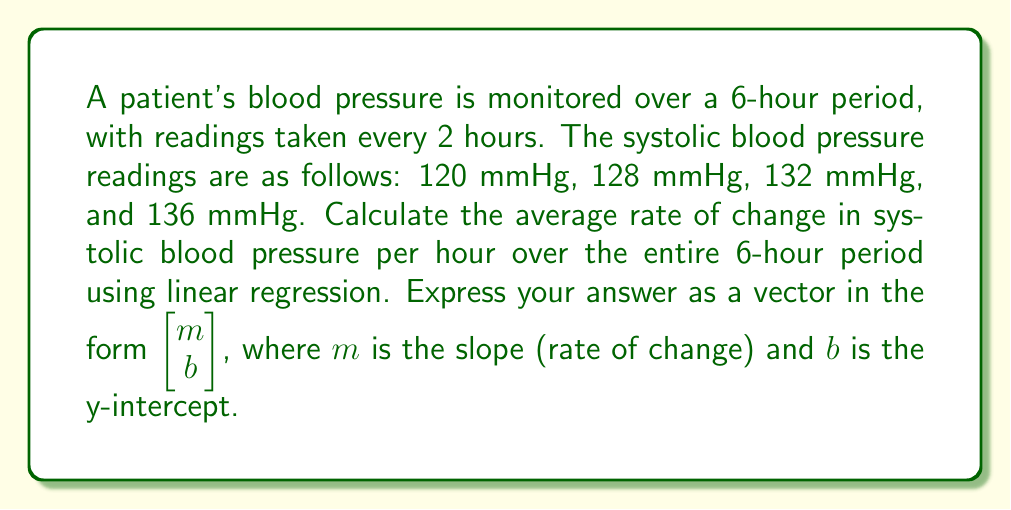What is the answer to this math problem? To solve this problem, we'll use linear regression to find the line of best fit for the blood pressure readings over time. We'll use the following steps:

1) Set up the data points:
   $x$ (hours): 0, 2, 4, 6
   $y$ (mmHg): 120, 128, 132, 136

2) Calculate the means of $x$ and $y$:
   $\bar{x} = \frac{0 + 2 + 4 + 6}{4} = 3$
   $\bar{y} = \frac{120 + 128 + 132 + 136}{4} = 129$

3) Calculate the slope $m$ using the formula:
   $$m = \frac{\sum(x_i - \bar{x})(y_i - \bar{y})}{\sum(x_i - \bar{x})^2}$$

4) Compute the numerator and denominator:
   $\sum(x_i - \bar{x})(y_i - \bar{y}) = (-3)(-9) + (-1)(-1) + (1)(3) + (3)(7) = 27 + 1 + 3 + 21 = 52$
   $\sum(x_i - \bar{x})^2 = (-3)^2 + (-1)^2 + (1)^2 + (3)^2 = 9 + 1 + 1 + 9 = 20$

5) Calculate the slope:
   $m = \frac{52}{20} = 2.6$

6) Calculate the y-intercept $b$ using the formula:
   $b = \bar{y} - m\bar{x} = 129 - 2.6(3) = 129 - 7.8 = 121.2$

Therefore, the line of best fit is $y = 2.6x + 121.2$, where $y$ is the systolic blood pressure in mmHg and $x$ is the time in hours.

The slope $m = 2.6$ represents the average rate of change in systolic blood pressure per hour over the 6-hour period.
Answer: $$\begin{bmatrix} 2.6 \\ 121.2 \end{bmatrix}$$ 